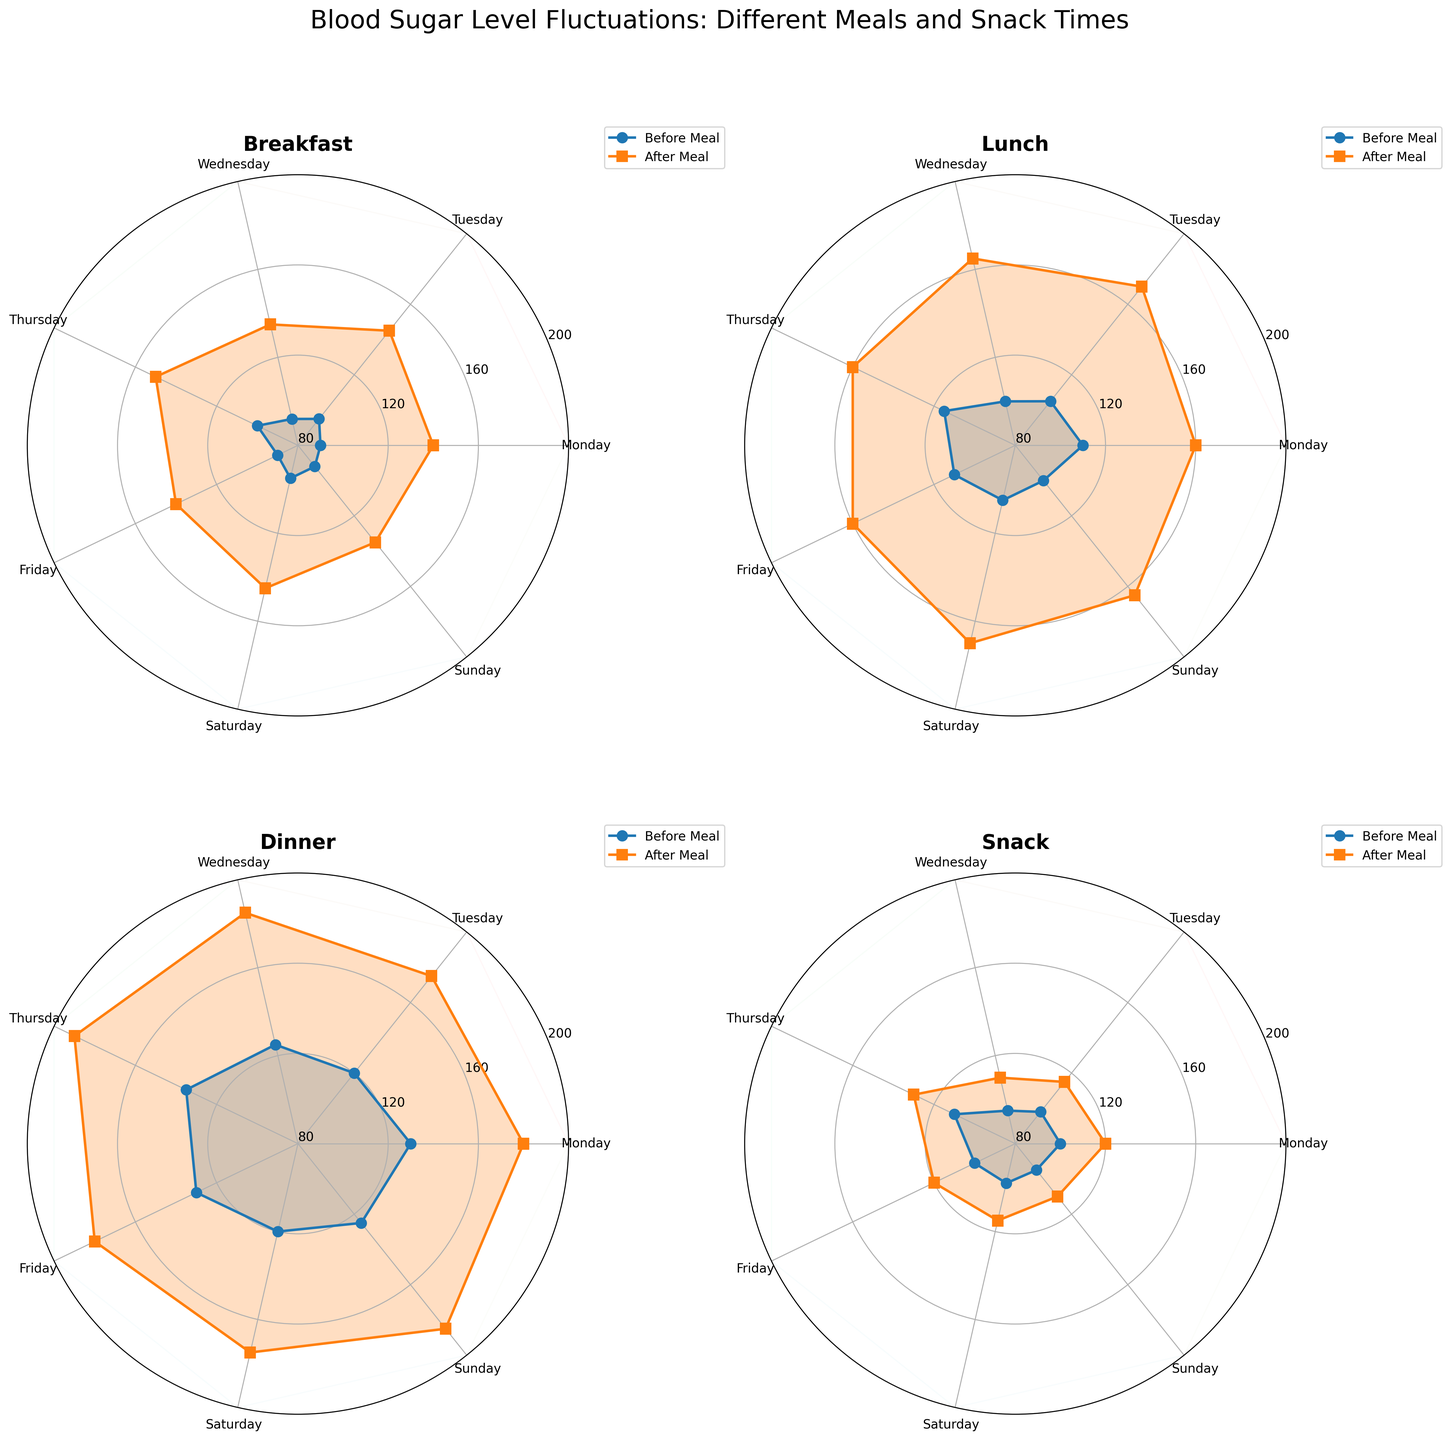What is the title of the figure? The title is usually found at the top of the figure, providing an overview of what the figure represents. Here, it reads "Blood Sugar Level Fluctuations: Different Meals and Snack Times".
Answer: Blood Sugar Level Fluctuations: Different Meals and Snack Times Which meal type shows the highest blood sugar level after the meal on average? To find out which meal type shows the highest blood sugar level after the meal on average, we need to compare the after-meal blood sugar values of all 4 meal types and determine which one has the highest average value. By visually inspecting the charts, it appears that Dinner consistently has higher values than other meals.
Answer: Dinner What blood sugar value range is used for the y-axis? The y-axis is used to display the range of blood sugar levels in the figure. By observing the radial labels, the range is clearly from 80 mg/dL to 200 mg/dL.
Answer: 80 to 200 mg/dL On which day does breakfast show the lowest blood sugar before the meal? To determine the day with the lowest blood sugar before breakfast, look at the "Before Meal" data points for breakfast across all days. By observing the chart, Sunday shows the lowest value.
Answer: Sunday How many data points are there for each meal type per week? Each meal type has data points representing the blood sugar levels before and after meals for all seven days of the week. So, for each meal type, there are 7 data points before and 7 data points after, making it 14 data points per meal type per week.
Answer: 14 What is the difference in blood sugar levels before and after lunch on Wednesday? To find the difference, we look at the data points for Wednesday’s lunch on the lunch subplot. The value before the meal is 100 mg/dL, and after the meal, it’s 165 mg/dL. The difference is calculated as 165 - 100.
Answer: 65 mg/dL Which day shows the minimal increase in blood sugar levels after a snack? To identify the day with the minimal increase, subtract the "Blood Sugar Before" value from the "Blood Sugar After" value for each snack across the days. By visual inspection, Tuesday's snack shows the smallest increase.
Answer: Tuesday On which weekday does dinner show the highest blood sugar before the meal? Look at the "Before Meal" data points for dinner across each weekday. According to the graph, Thursday shows the highest blood sugar level before dinner.
Answer: Thursday Which meal type shows the most consistent blood sugar levels before and after meals throughout the week? Consistency refers to the least variation in blood sugar levels throughout the week. By observing the plots, the snack subplot exhibits relatively consistent levels before and after meals compared to others.
Answer: Snack For breakfast on Thursday, what are the blood sugar levels before and after the meal? To find these values, inspect the breakfast subplot for Thursday. The values are distinguished as circular markers for before and square markers for after. For Thursday, before is 100 mg/dL, and after is 150 mg/dL.
Answer: 100 mg/dL, 150 mg/dL 